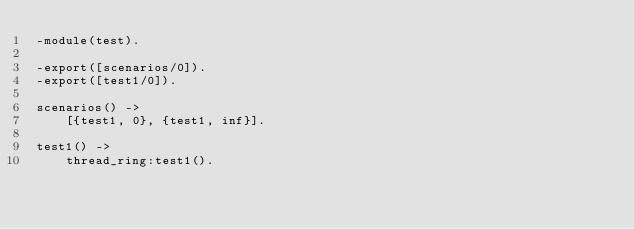Convert code to text. <code><loc_0><loc_0><loc_500><loc_500><_Erlang_>-module(test).

-export([scenarios/0]).
-export([test1/0]).

scenarios() ->
    [{test1, 0}, {test1, inf}].

test1() ->
    thread_ring:test1().
</code> 